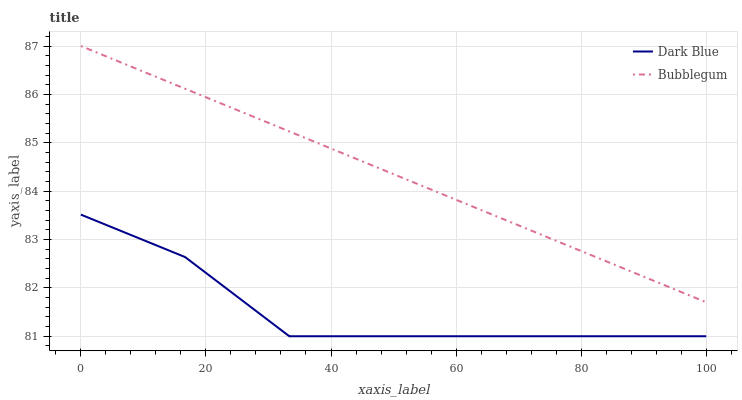Does Dark Blue have the minimum area under the curve?
Answer yes or no. Yes. Does Bubblegum have the maximum area under the curve?
Answer yes or no. Yes. Does Bubblegum have the minimum area under the curve?
Answer yes or no. No. Is Bubblegum the smoothest?
Answer yes or no. Yes. Is Dark Blue the roughest?
Answer yes or no. Yes. Is Bubblegum the roughest?
Answer yes or no. No. Does Dark Blue have the lowest value?
Answer yes or no. Yes. Does Bubblegum have the lowest value?
Answer yes or no. No. Does Bubblegum have the highest value?
Answer yes or no. Yes. Is Dark Blue less than Bubblegum?
Answer yes or no. Yes. Is Bubblegum greater than Dark Blue?
Answer yes or no. Yes. Does Dark Blue intersect Bubblegum?
Answer yes or no. No. 